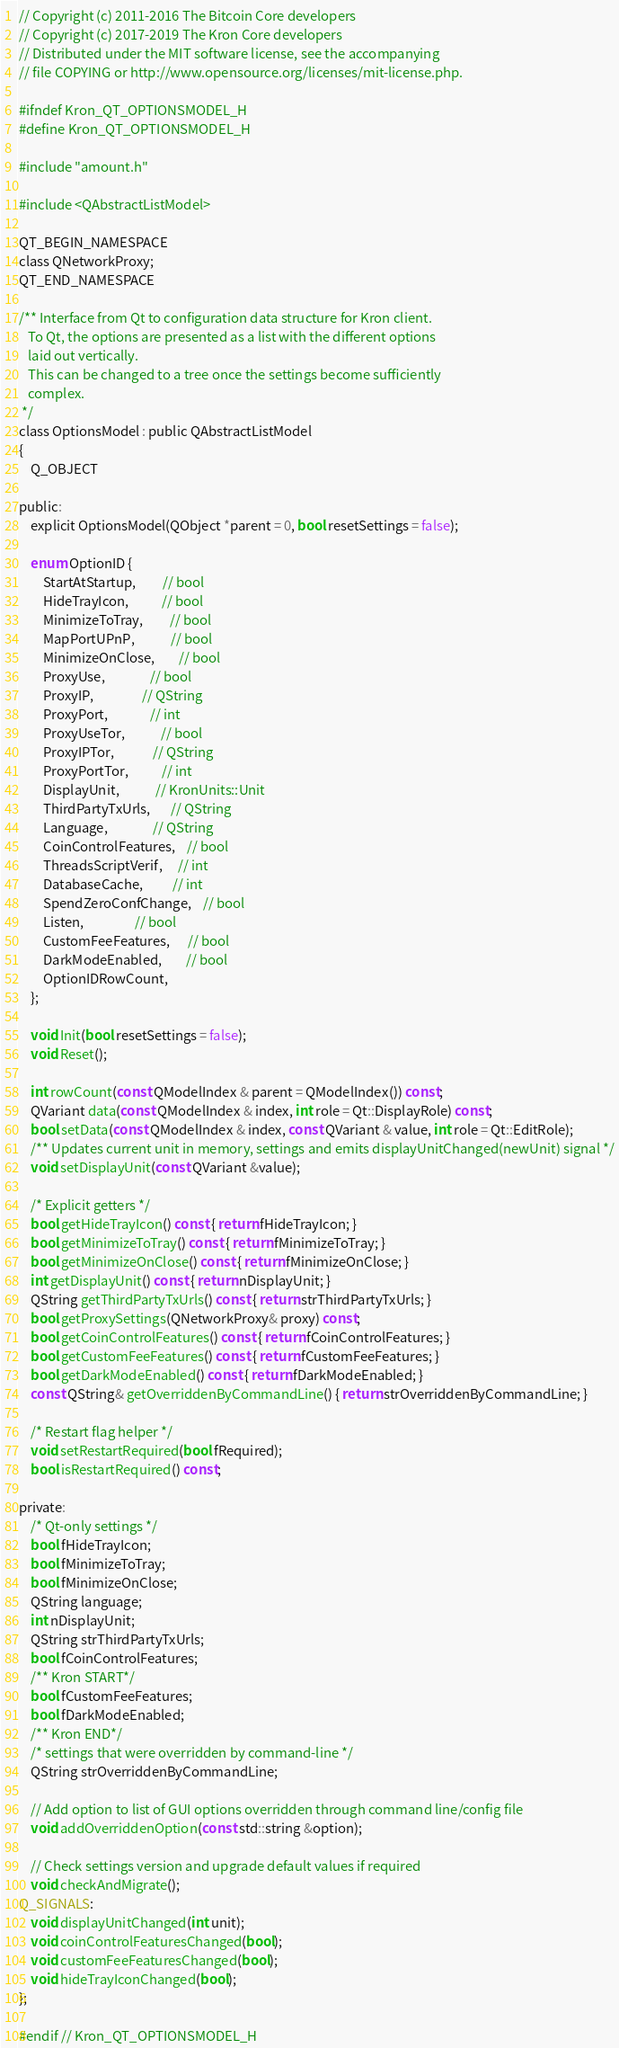Convert code to text. <code><loc_0><loc_0><loc_500><loc_500><_C_>// Copyright (c) 2011-2016 The Bitcoin Core developers
// Copyright (c) 2017-2019 The Kron Core developers
// Distributed under the MIT software license, see the accompanying
// file COPYING or http://www.opensource.org/licenses/mit-license.php.

#ifndef Kron_QT_OPTIONSMODEL_H
#define Kron_QT_OPTIONSMODEL_H

#include "amount.h"

#include <QAbstractListModel>

QT_BEGIN_NAMESPACE
class QNetworkProxy;
QT_END_NAMESPACE

/** Interface from Qt to configuration data structure for Kron client.
   To Qt, the options are presented as a list with the different options
   laid out vertically.
   This can be changed to a tree once the settings become sufficiently
   complex.
 */
class OptionsModel : public QAbstractListModel
{
    Q_OBJECT

public:
    explicit OptionsModel(QObject *parent = 0, bool resetSettings = false);

    enum OptionID {
        StartAtStartup,         // bool
        HideTrayIcon,           // bool
        MinimizeToTray,         // bool
        MapPortUPnP,            // bool
        MinimizeOnClose,        // bool
        ProxyUse,               // bool
        ProxyIP,                // QString
        ProxyPort,              // int
        ProxyUseTor,            // bool
        ProxyIPTor,             // QString
        ProxyPortTor,           // int
        DisplayUnit,            // KronUnits::Unit
        ThirdPartyTxUrls,       // QString
        Language,               // QString
        CoinControlFeatures,    // bool
        ThreadsScriptVerif,     // int
        DatabaseCache,          // int
        SpendZeroConfChange,    // bool
        Listen,                 // bool
        CustomFeeFeatures,      // bool
        DarkModeEnabled,        // bool
        OptionIDRowCount,
    };

    void Init(bool resetSettings = false);
    void Reset();

    int rowCount(const QModelIndex & parent = QModelIndex()) const;
    QVariant data(const QModelIndex & index, int role = Qt::DisplayRole) const;
    bool setData(const QModelIndex & index, const QVariant & value, int role = Qt::EditRole);
    /** Updates current unit in memory, settings and emits displayUnitChanged(newUnit) signal */
    void setDisplayUnit(const QVariant &value);

    /* Explicit getters */
    bool getHideTrayIcon() const { return fHideTrayIcon; }
    bool getMinimizeToTray() const { return fMinimizeToTray; }
    bool getMinimizeOnClose() const { return fMinimizeOnClose; }
    int getDisplayUnit() const { return nDisplayUnit; }
    QString getThirdPartyTxUrls() const { return strThirdPartyTxUrls; }
    bool getProxySettings(QNetworkProxy& proxy) const;
    bool getCoinControlFeatures() const { return fCoinControlFeatures; }
    bool getCustomFeeFeatures() const { return fCustomFeeFeatures; }
    bool getDarkModeEnabled() const { return fDarkModeEnabled; }
    const QString& getOverriddenByCommandLine() { return strOverriddenByCommandLine; }

    /* Restart flag helper */
    void setRestartRequired(bool fRequired);
    bool isRestartRequired() const;

private:
    /* Qt-only settings */
    bool fHideTrayIcon;
    bool fMinimizeToTray;
    bool fMinimizeOnClose;
    QString language;
    int nDisplayUnit;
    QString strThirdPartyTxUrls;
    bool fCoinControlFeatures;
    /** Kron START*/
    bool fCustomFeeFeatures;
    bool fDarkModeEnabled;
    /** Kron END*/
    /* settings that were overridden by command-line */
    QString strOverriddenByCommandLine;

    // Add option to list of GUI options overridden through command line/config file
    void addOverriddenOption(const std::string &option);

    // Check settings version and upgrade default values if required
    void checkAndMigrate();
Q_SIGNALS:
    void displayUnitChanged(int unit);
    void coinControlFeaturesChanged(bool);
    void customFeeFeaturesChanged(bool);
    void hideTrayIconChanged(bool);
};

#endif // Kron_QT_OPTIONSMODEL_H
</code> 